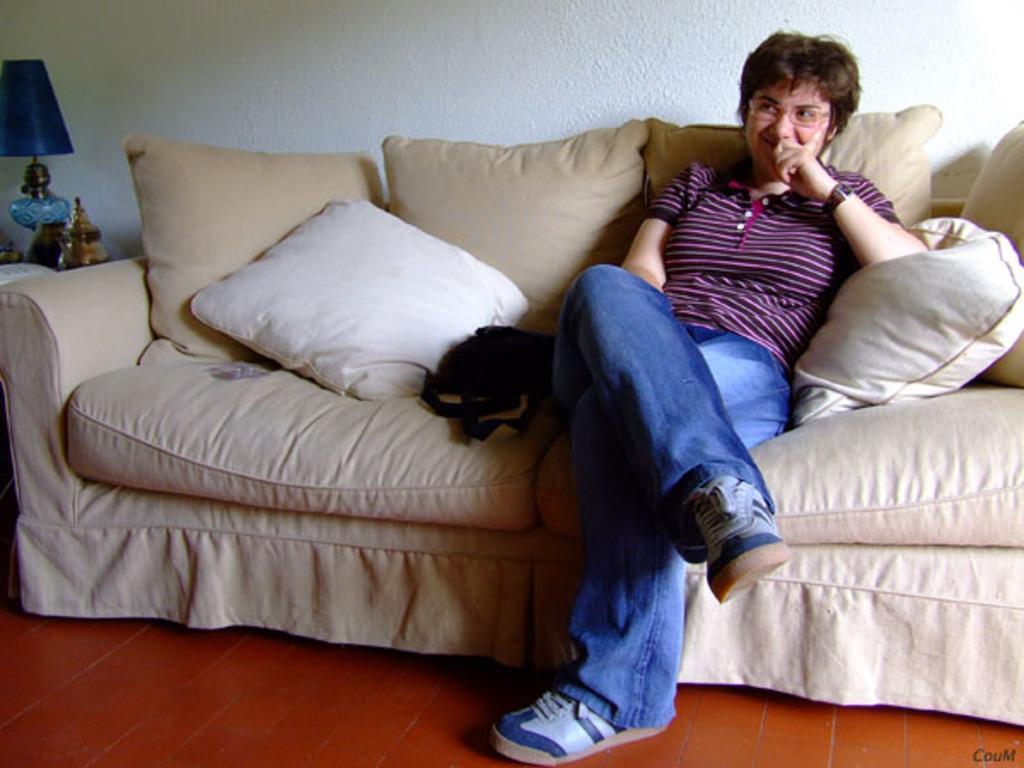How would you summarize this image in a sentence or two? In this picture we can see one woman is sitting on a sofa, sofa consists of two pillows in the background we can see a wall, on the left side of this image we can see a lamp. 